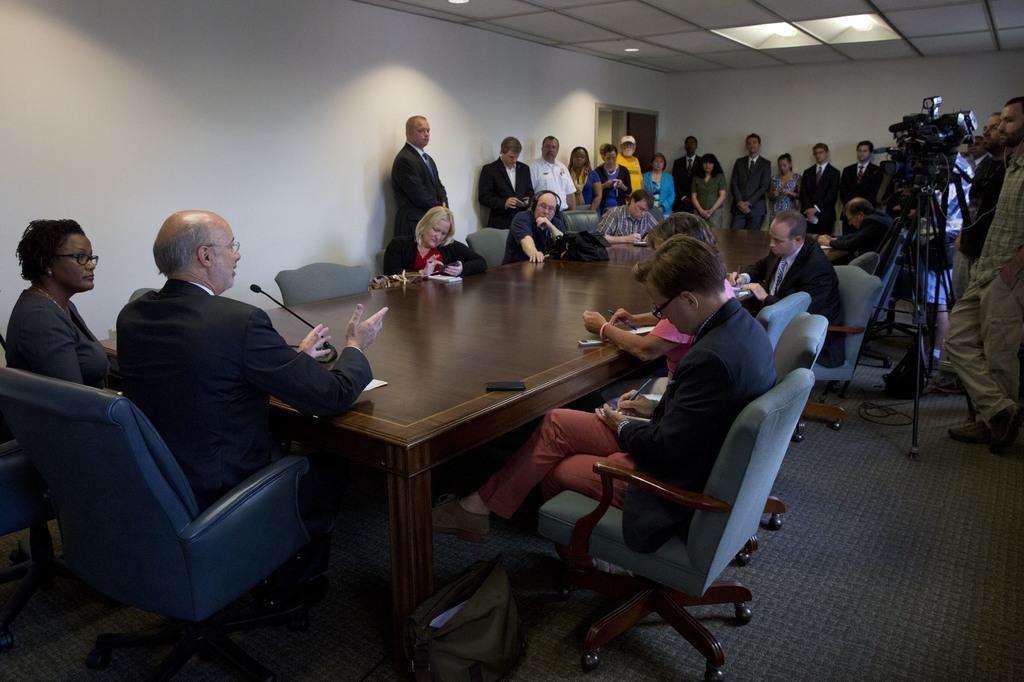In one or two sentences, can you explain what this image depicts? This picture shows a group of people seated on the chairs and a person speaking with the help of a microphone and we see few people standing and a person standing and holding a camera. 